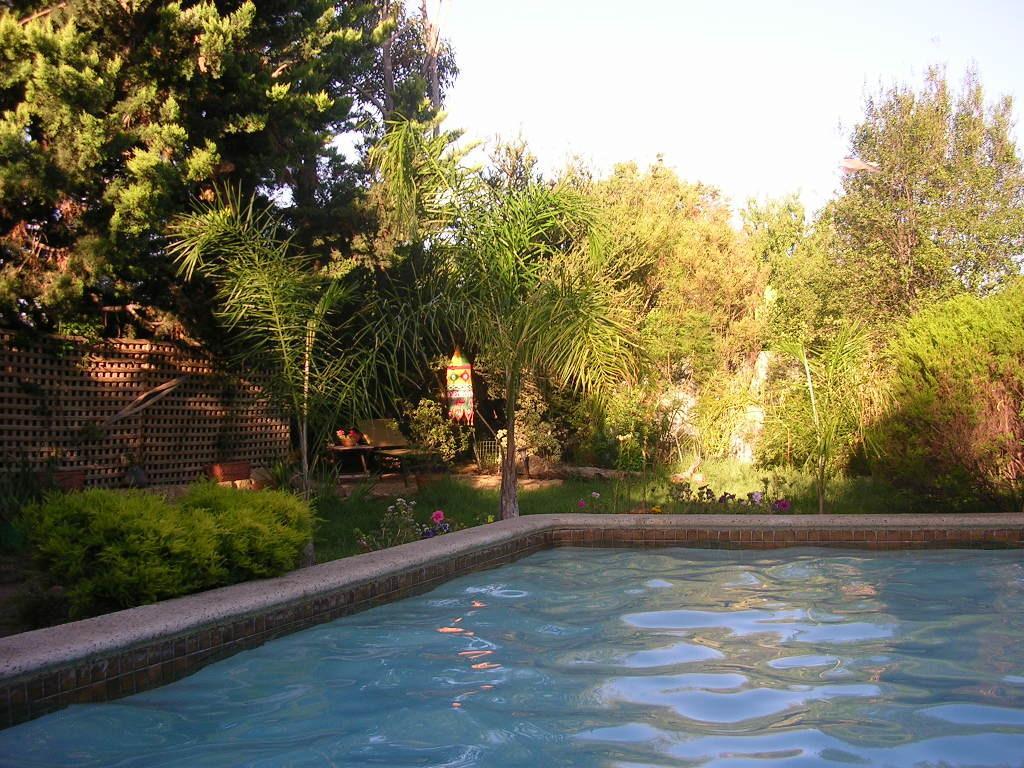Could you give a brief overview of what you see in this image? In this picture we can see the water in the pond. There are plants, flowers, wooden objects, other objects and the sky. 